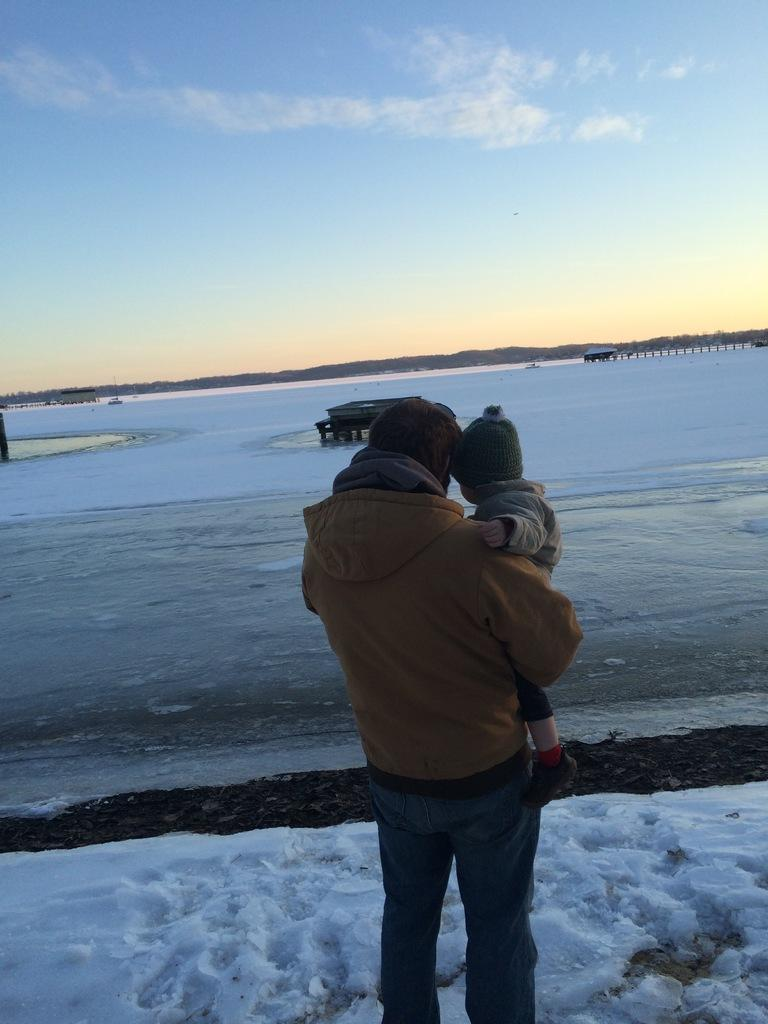What is the person in the image doing? The person is holding a baby in the image. What are the person and the baby wearing? Both the person and the baby are wearing caps. What is the condition of the ground in the image? There is snow on the ground in the image. What can be seen in the background of the image? There are objects and the sky visible in the background of the image. What is the weather like in the image? The presence of snow on the ground and clouds in the sky suggest it is a cold and possibly snowy day. What type of plastic is used to make the baby's income in the image? There is no mention of a baby's income in the image, and plastic is not relevant to the subjects or setting. 